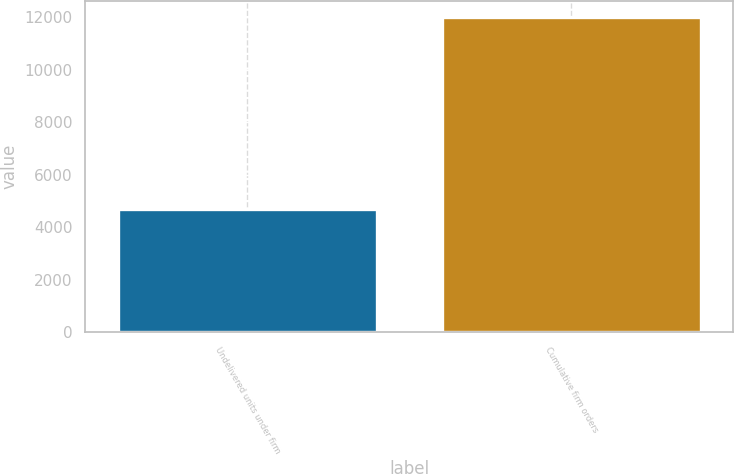<chart> <loc_0><loc_0><loc_500><loc_500><bar_chart><fcel>Undelivered units under firm<fcel>Cumulative firm orders<nl><fcel>4708<fcel>12020<nl></chart> 